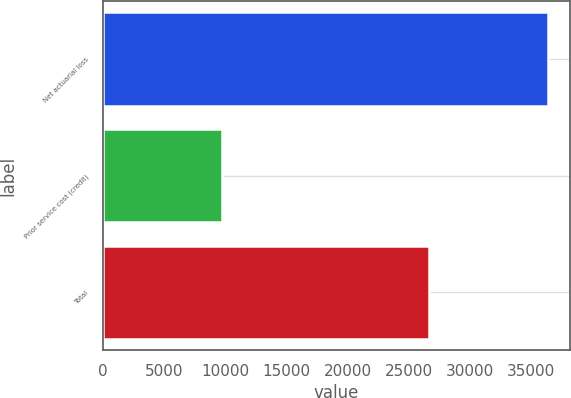Convert chart. <chart><loc_0><loc_0><loc_500><loc_500><bar_chart><fcel>Net actuarial loss<fcel>Prior service cost (credit)<fcel>Total<nl><fcel>36355<fcel>9745<fcel>26610<nl></chart> 